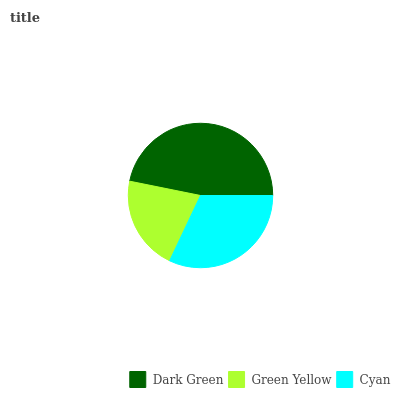Is Green Yellow the minimum?
Answer yes or no. Yes. Is Dark Green the maximum?
Answer yes or no. Yes. Is Cyan the minimum?
Answer yes or no. No. Is Cyan the maximum?
Answer yes or no. No. Is Cyan greater than Green Yellow?
Answer yes or no. Yes. Is Green Yellow less than Cyan?
Answer yes or no. Yes. Is Green Yellow greater than Cyan?
Answer yes or no. No. Is Cyan less than Green Yellow?
Answer yes or no. No. Is Cyan the high median?
Answer yes or no. Yes. Is Cyan the low median?
Answer yes or no. Yes. Is Green Yellow the high median?
Answer yes or no. No. Is Dark Green the low median?
Answer yes or no. No. 